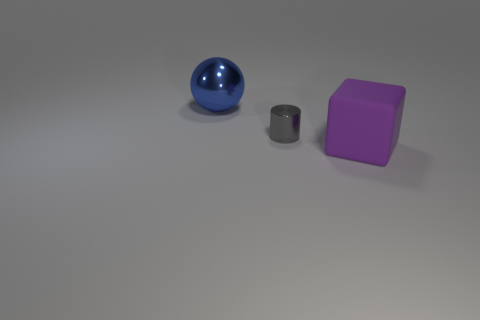Add 2 blue balls. How many objects exist? 5 Subtract all cylinders. How many objects are left? 2 Subtract all large gray rubber things. Subtract all big blue things. How many objects are left? 2 Add 1 large purple rubber objects. How many large purple rubber objects are left? 2 Add 2 tiny yellow cylinders. How many tiny yellow cylinders exist? 2 Subtract 0 purple spheres. How many objects are left? 3 